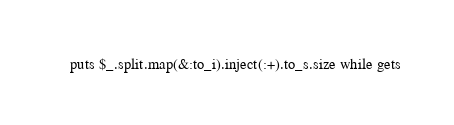<code> <loc_0><loc_0><loc_500><loc_500><_Ruby_>puts $_.split.map(&:to_i).inject(:+).to_s.size while gets</code> 